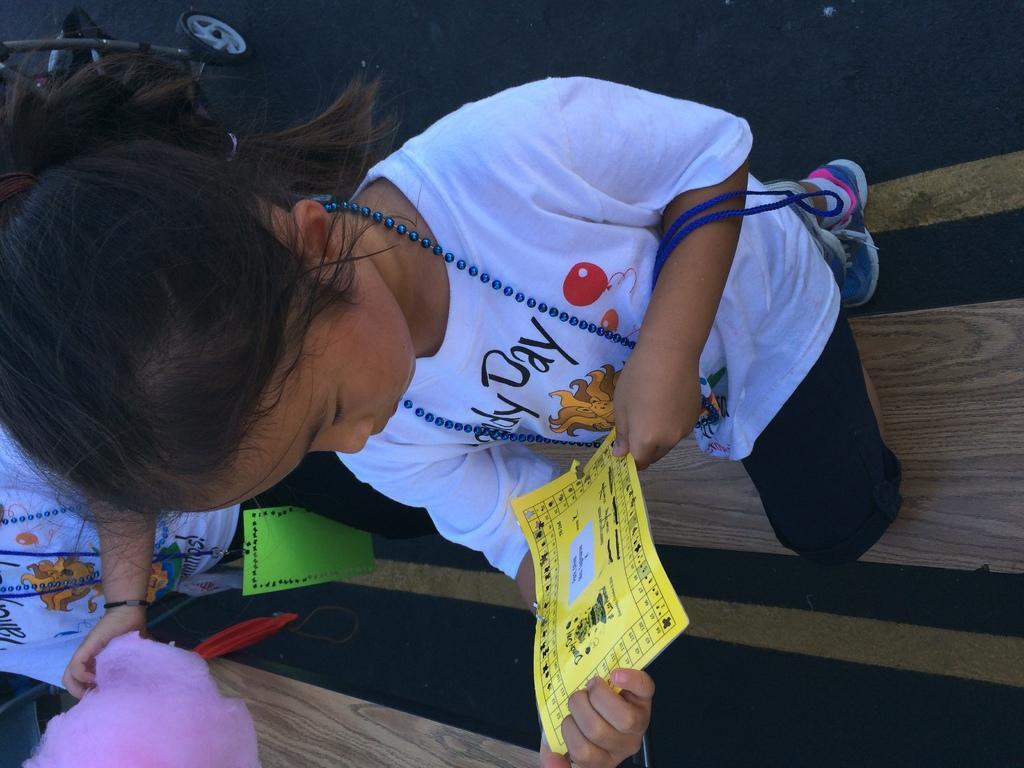Describe this image in one or two sentences. This picture seems to be clicked outside. In the center there is a kid wearing white color t-shirt, holding paper and standing with his one leg on the wooden bench. In the background we can see the ground and some other objects. 